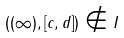<formula> <loc_0><loc_0><loc_500><loc_500>( ( \infty ) , [ c , d ] ) \notin I</formula> 